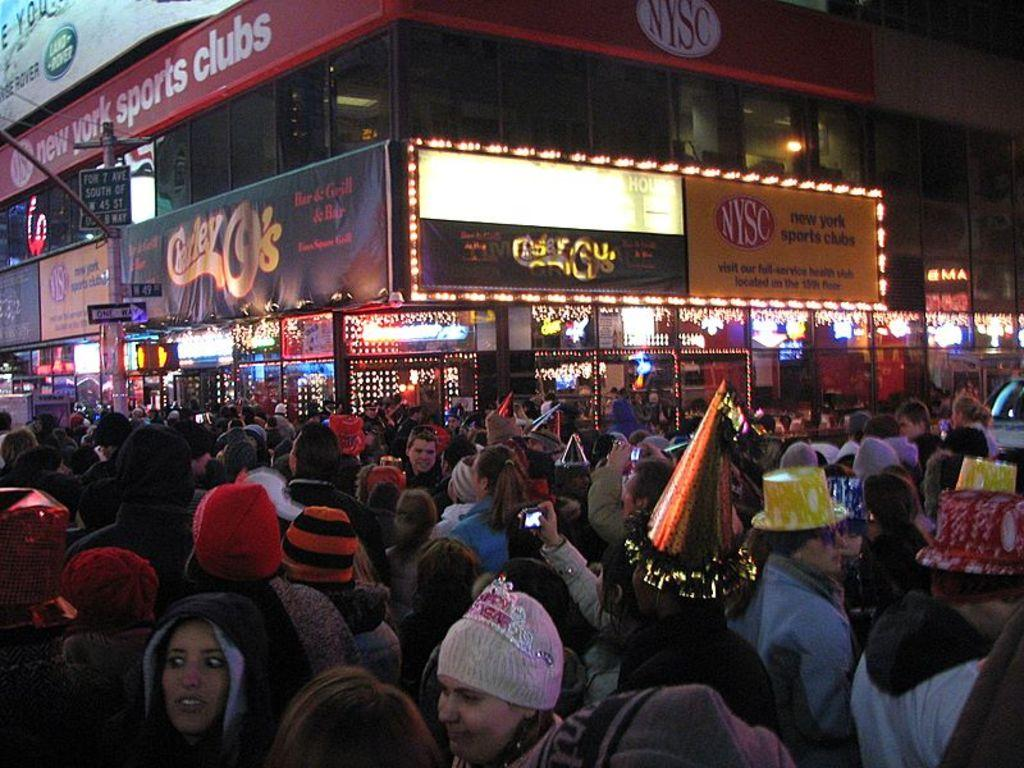How many people are in the group in the image? There is a group of people in the image, but the exact number is not specified. Where are the people standing in the image? The people are standing on the road in the image. What are some people in the group wearing? Some people in the group are wearing hats. What can be seen in the background of the image? There is a building visible in the background. What features does the building have? The building has lighting and boards. What type of lunch is being served in the image? There is no lunch present in the image; it features a group of people standing on the road with a building in the background. 